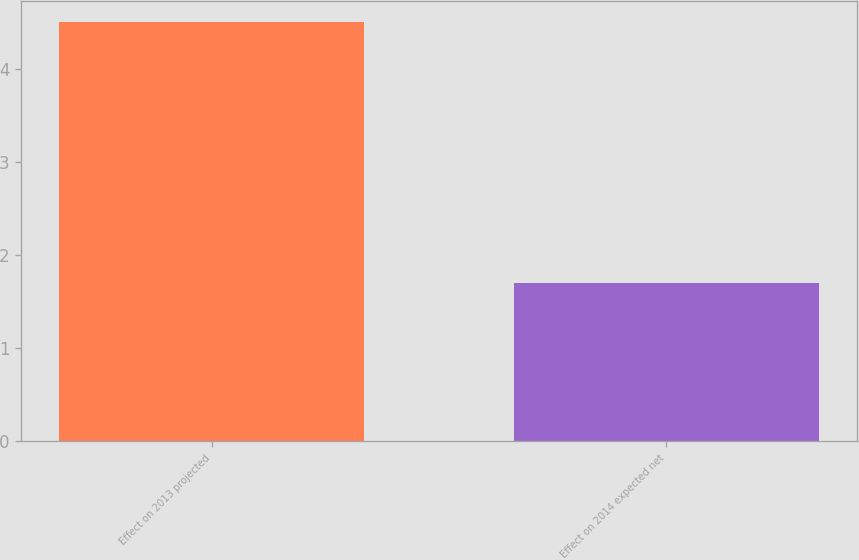Convert chart to OTSL. <chart><loc_0><loc_0><loc_500><loc_500><bar_chart><fcel>Effect on 2013 projected<fcel>Effect on 2014 expected net<nl><fcel>4.5<fcel>1.7<nl></chart> 